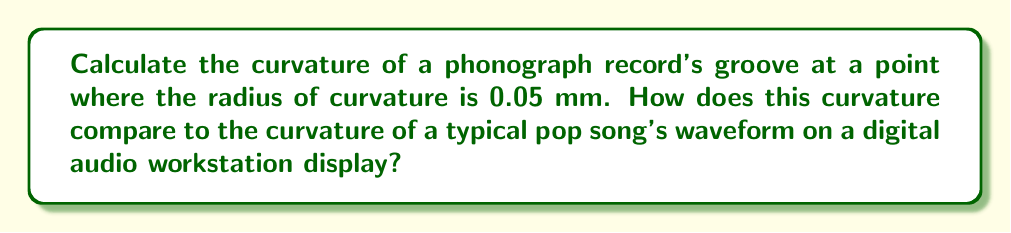Can you solve this math problem? Let's approach this step-by-step:

1) The curvature $\kappa$ of a curve at a point is defined as the reciprocal of the radius of curvature $R$ at that point:

   $$\kappa = \frac{1}{R}$$

2) We are given that the radius of curvature is 0.05 mm. Let's convert this to meters:

   $$R = 0.05 \text{ mm} = 5 \times 10^{-5} \text{ m}$$

3) Now we can calculate the curvature:

   $$\kappa = \frac{1}{5 \times 10^{-5}} = 2 \times 10^4 \text{ m}^{-1}$$

4) To compare this to a typical pop song's waveform on a digital audio workstation (DAW) display, we need to consider that DAW waveforms are usually much less curved. A typical waveform might have a radius of curvature on the order of centimeters or even meters when displayed on a screen.

5) Let's assume a radius of curvature of 10 cm for a pop song waveform on a DAW:

   $$R_{\text{DAW}} = 10 \text{ cm} = 0.1 \text{ m}$$

6) The curvature of the DAW waveform would then be:

   $$\kappa_{\text{DAW}} = \frac{1}{0.1} = 10 \text{ m}^{-1}$$

7) Comparing the two:

   $$\frac{\kappa_{\text{phonograph}}}{\kappa_{\text{DAW}}} = \frac{2 \times 10^4}{10} = 2 \times 10^3$$

This means the curvature of the phonograph groove is about 2000 times greater than the curvature of a typical pop song waveform on a DAW display.
Answer: $2 \times 10^4 \text{ m}^{-1}$; 2000 times greater 